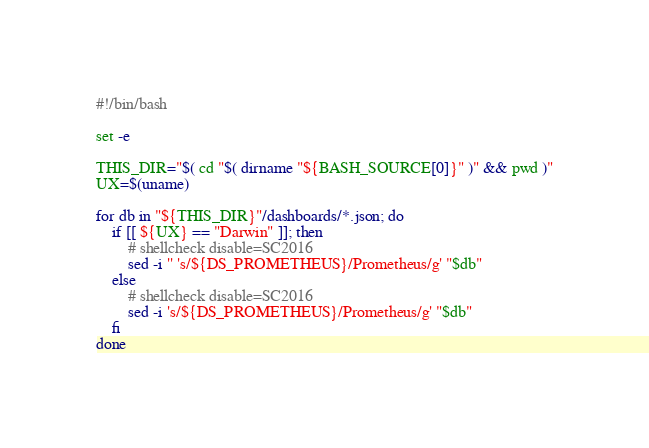<code> <loc_0><loc_0><loc_500><loc_500><_Bash_>#!/bin/bash

set -e

THIS_DIR="$( cd "$( dirname "${BASH_SOURCE[0]}" )" && pwd )"
UX=$(uname)

for db in "${THIS_DIR}"/dashboards/*.json; do
    if [[ ${UX} == "Darwin" ]]; then
        # shellcheck disable=SC2016
        sed -i '' 's/${DS_PROMETHEUS}/Prometheus/g' "$db"
    else
        # shellcheck disable=SC2016
        sed -i 's/${DS_PROMETHEUS}/Prometheus/g' "$db"
    fi
done
</code> 